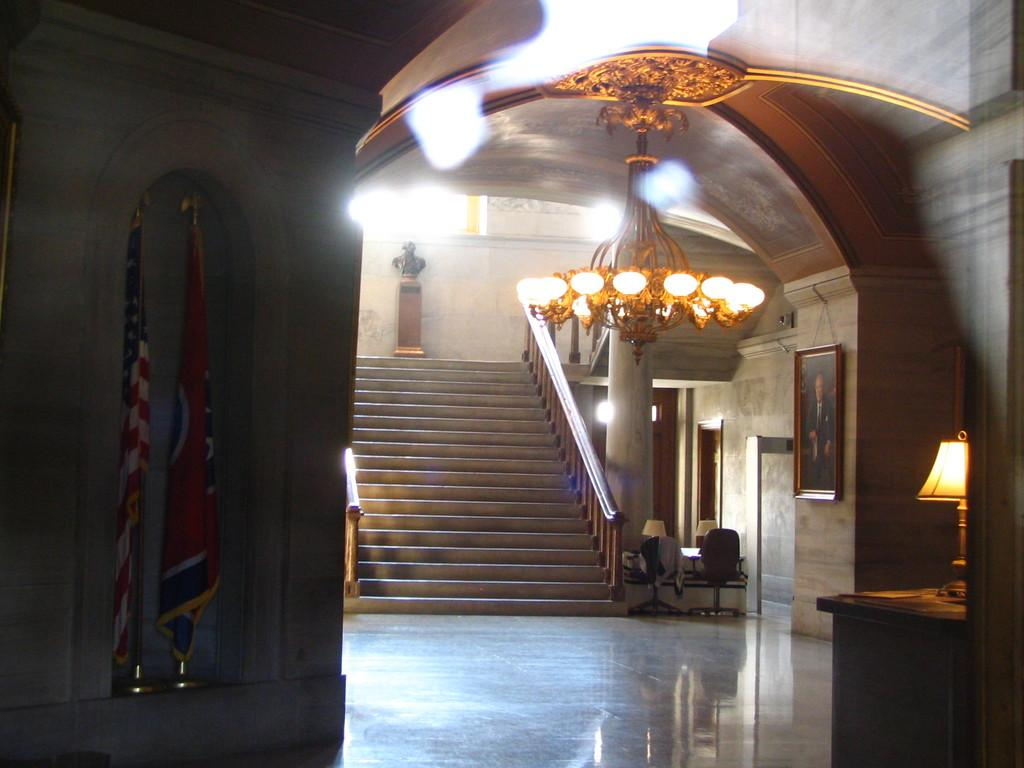What is located in the middle of the image? There are lights in the middle of the image. What architectural feature can be seen in the image? There is a staircase in the image. Where are the flags positioned in the image? There are two flags on the left side of the image. What type of lace can be seen draped over the staircase in the image? There is no lace present in the image; it only features lights, a staircase, and two flags. What is the floor made of in the image? The provided facts do not mention the floor or its material, so it cannot be determined from the image. 